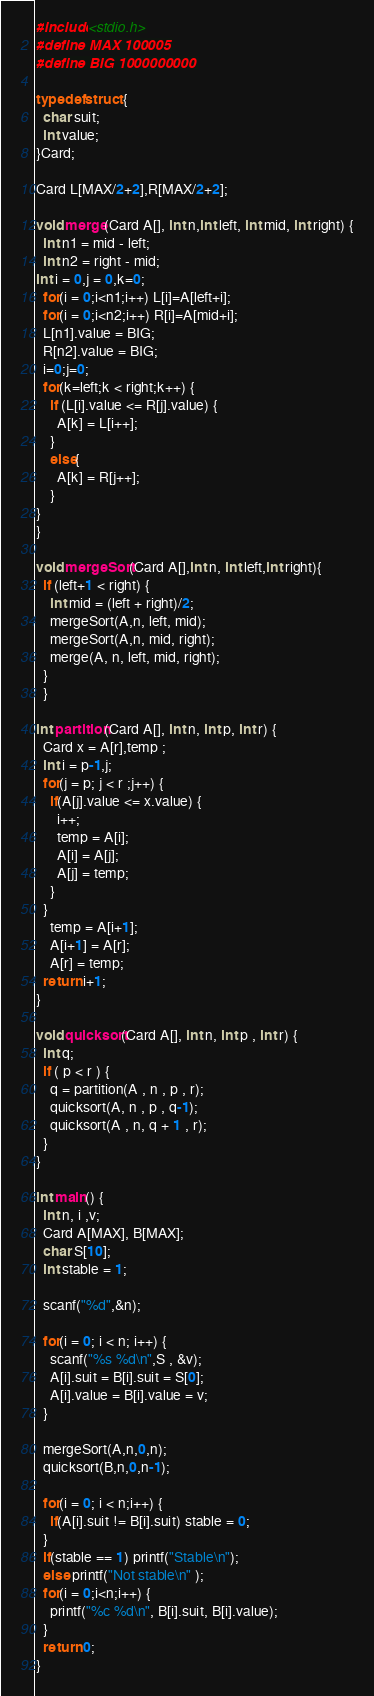<code> <loc_0><loc_0><loc_500><loc_500><_C_>#include<stdio.h>
#define MAX 100005
#define BIG 1000000000

typedef struct {
  char suit;
  int value;
}Card;

Card L[MAX/2+2],R[MAX/2+2];

void merge(Card A[], int n,int left, int mid, int right) {
  int n1 = mid - left;
  int n2 = right - mid;
int i = 0,j = 0,k=0;
  for(i = 0;i<n1;i++) L[i]=A[left+i];
  for(i = 0;i<n2;i++) R[i]=A[mid+i];
  L[n1].value = BIG;
  R[n2].value = BIG;
  i=0;j=0;
  for(k=left;k < right;k++) {
    if (L[i].value <= R[j].value) {
      A[k] = L[i++];
    }
    else{
      A[k] = R[j++];
    }
}
}

void mergeSort(Card A[],int n, int left,int right){
  if (left+1 < right) {
    int mid = (left + right)/2;
    mergeSort(A,n, left, mid);
    mergeSort(A,n, mid, right);
    merge(A, n, left, mid, right);
  }
  }

int partition(Card A[], int n, int p, int r) {
  Card x = A[r],temp ;
  int i = p-1,j;
  for(j = p; j < r ;j++) {
    if(A[j].value <= x.value) {
      i++;
      temp = A[i];
      A[i] = A[j];
      A[j] = temp;
    }
  }
    temp = A[i+1];
    A[i+1] = A[r];
    A[r] = temp;
  return i+1;
}

void quicksort(Card A[], int n, int p , int r) {
  int q;
  if ( p < r ) {
    q = partition(A , n , p , r);
    quicksort(A, n , p , q-1);
    quicksort(A , n, q + 1 , r);
  }
}

int main() {
  int n, i ,v;
  Card A[MAX], B[MAX];
  char S[10];
  int stable = 1;

  scanf("%d",&n);

  for(i = 0; i < n; i++) {
    scanf("%s %d\n",S , &v);
    A[i].suit = B[i].suit = S[0];
    A[i].value = B[i].value = v;
  }

  mergeSort(A,n,0,n);
  quicksort(B,n,0,n-1);

  for(i = 0; i < n;i++) {
    if(A[i].suit != B[i].suit) stable = 0;
  }
  if(stable == 1) printf("Stable\n");
  else printf("Not stable\n" );
  for(i = 0;i<n;i++) {
    printf("%c %d\n", B[i].suit, B[i].value);
  }
  return 0;
}</code> 